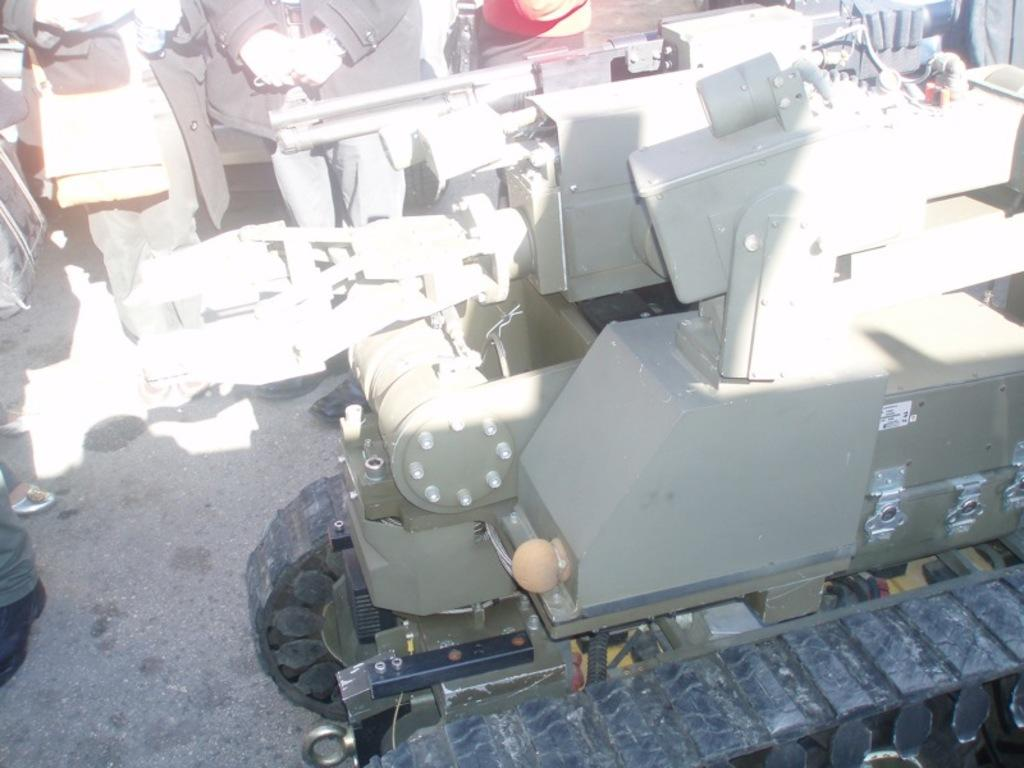What is the main subject of the image? The main subject of the image is a vehicle. Can you describe the colors of the vehicle? The vehicle has green and black colors. What else can be seen in the background of the image? There are people standing in the background of the image. How many potatoes are being used as a bell in the image? There are no potatoes or bells present in the image; it features a vehicle with green and black colors and people standing in the background. 